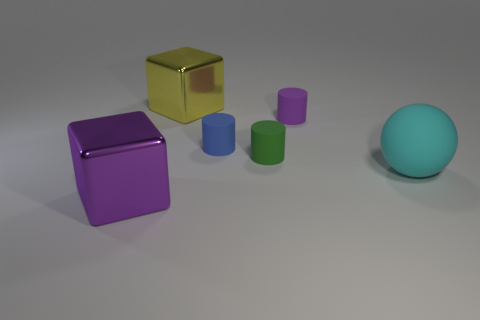Subtract all blue cylinders. How many cylinders are left? 2 Add 2 yellow metal objects. How many objects exist? 8 Subtract all green cylinders. How many cylinders are left? 2 Subtract all spheres. How many objects are left? 5 Subtract all cyan blocks. How many blue cylinders are left? 1 Subtract 0 gray cylinders. How many objects are left? 6 Subtract all red cylinders. Subtract all cyan spheres. How many cylinders are left? 3 Subtract all big purple objects. Subtract all cyan balls. How many objects are left? 4 Add 5 small cylinders. How many small cylinders are left? 8 Add 1 small objects. How many small objects exist? 4 